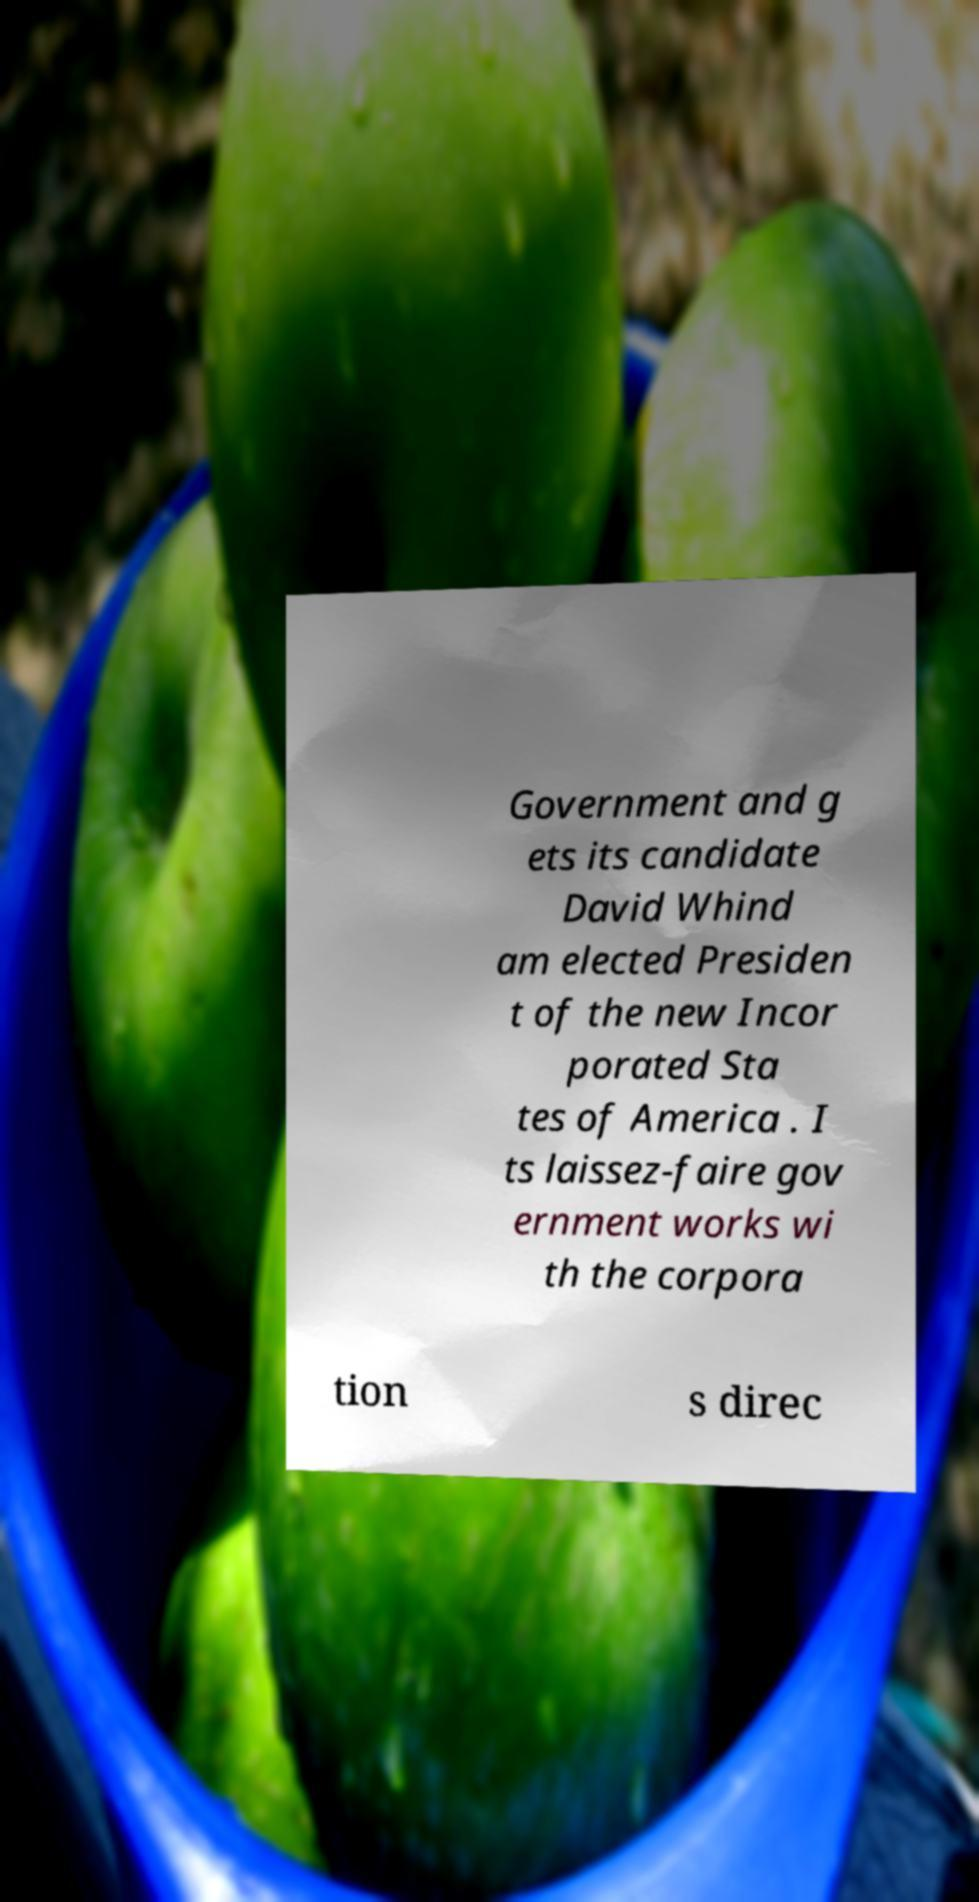I need the written content from this picture converted into text. Can you do that? Government and g ets its candidate David Whind am elected Presiden t of the new Incor porated Sta tes of America . I ts laissez-faire gov ernment works wi th the corpora tion s direc 